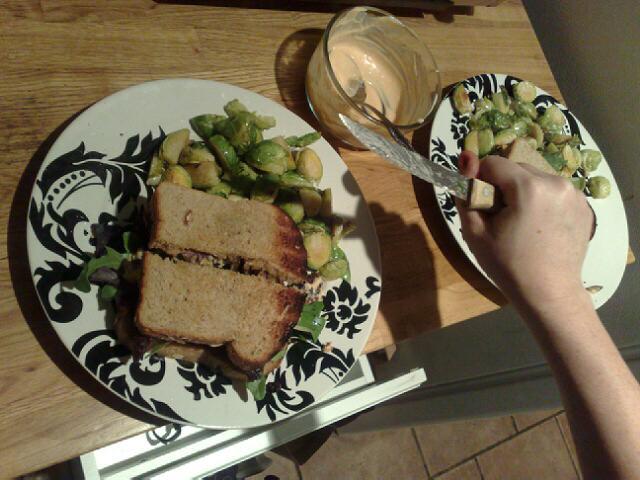What is the green vegetable on the plate?
Write a very short answer. Brussel sprouts. What is beside the sandwich?
Quick response, please. Vegetables. What kind of food is shown?
Be succinct. Sandwich. How big is the knife?
Short answer required. Small. Is the sandwich toasted?
Keep it brief. Yes. What utensil is on the plate?
Quick response, please. Knife. 